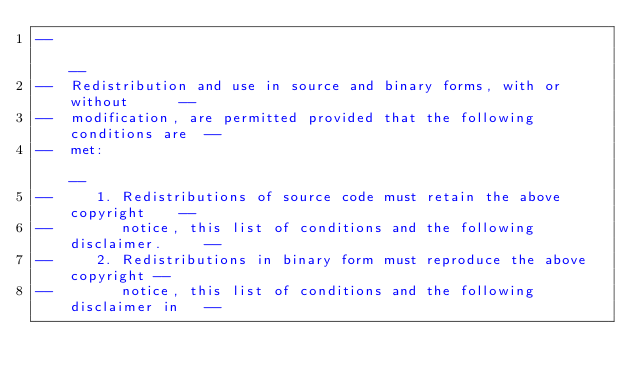<code> <loc_0><loc_0><loc_500><loc_500><_Ada_>--                                                                          --
--  Redistribution and use in source and binary forms, with or without      --
--  modification, are permitted provided that the following conditions are  --
--  met:                                                                    --
--     1. Redistributions of source code must retain the above copyright    --
--        notice, this list of conditions and the following disclaimer.     --
--     2. Redistributions in binary form must reproduce the above copyright --
--        notice, this list of conditions and the following disclaimer in   --</code> 